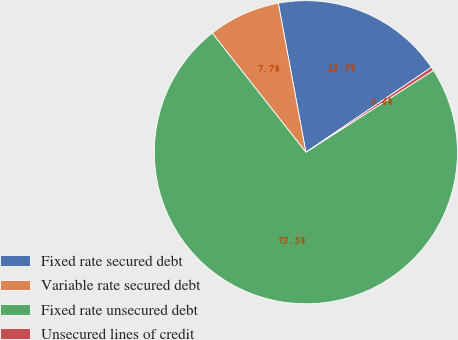Convert chart. <chart><loc_0><loc_0><loc_500><loc_500><pie_chart><fcel>Fixed rate secured debt<fcel>Variable rate secured debt<fcel>Fixed rate unsecured debt<fcel>Unsecured lines of credit<nl><fcel>18.45%<fcel>7.69%<fcel>73.48%<fcel>0.38%<nl></chart> 